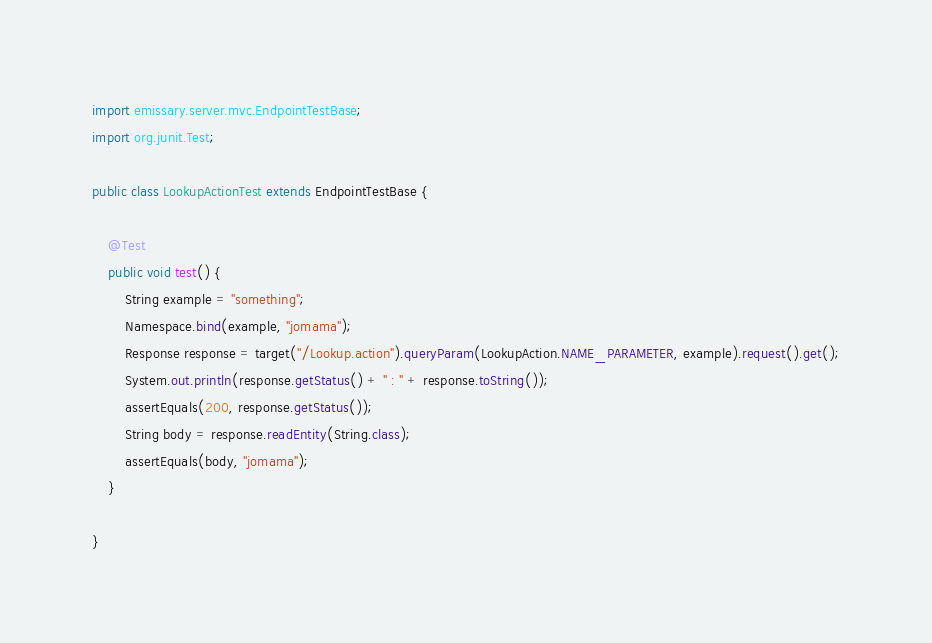<code> <loc_0><loc_0><loc_500><loc_500><_Java_>import emissary.server.mvc.EndpointTestBase;
import org.junit.Test;

public class LookupActionTest extends EndpointTestBase {

    @Test
    public void test() {
        String example = "something";
        Namespace.bind(example, "jomama");
        Response response = target("/Lookup.action").queryParam(LookupAction.NAME_PARAMETER, example).request().get();
        System.out.println(response.getStatus() + " : " + response.toString());
        assertEquals(200, response.getStatus());
        String body = response.readEntity(String.class);
        assertEquals(body, "jomama");
    }

}
</code> 